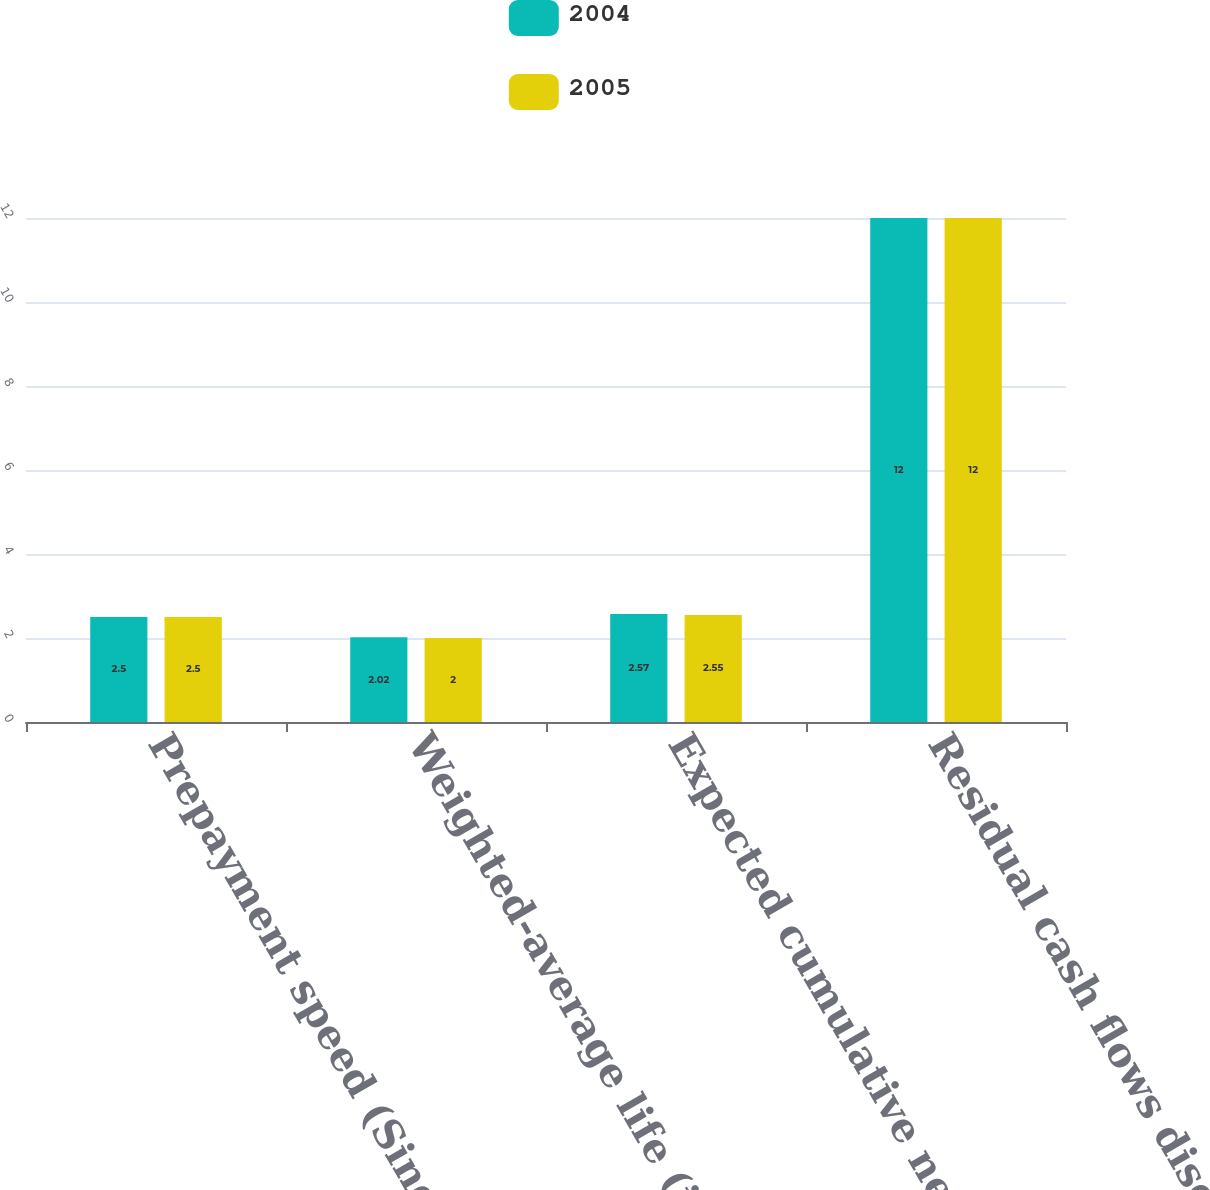Convert chart. <chart><loc_0><loc_0><loc_500><loc_500><stacked_bar_chart><ecel><fcel>Prepayment speed (Single<fcel>Weighted-average life (in<fcel>Expected cumulative net credit<fcel>Residual cash flows discount<nl><fcel>2004<fcel>2.5<fcel>2.02<fcel>2.57<fcel>12<nl><fcel>2005<fcel>2.5<fcel>2<fcel>2.55<fcel>12<nl></chart> 